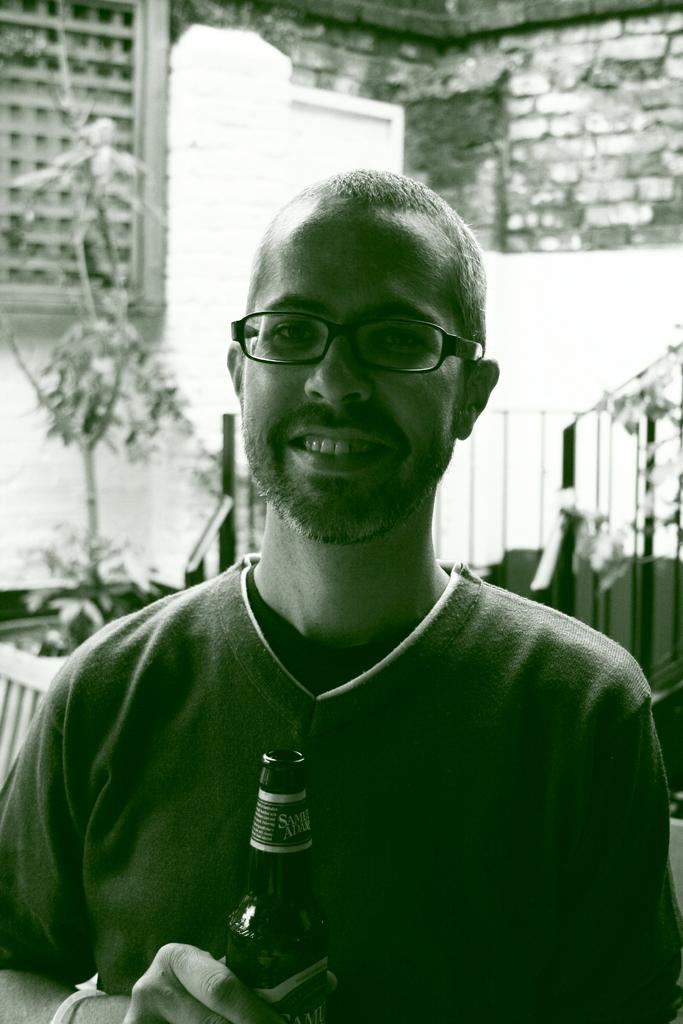Who is present in the image? There is a man in the image. What is the man wearing? The man is wearing spectacles. What is the man holding in his hand? The man is holding a bottle in his hand. What can be seen in the background of the image? There is a wall with bricks in the background of the image. What type of living organism is in the image? There is a plant in the image. What type of chicken is the man exchanging with the writer in the image? There is no chicken or writer present in the image. 